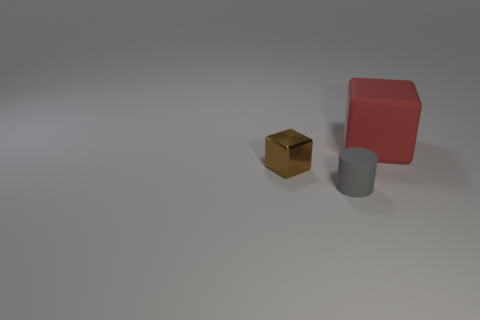Are there more gray cylinders that are in front of the tiny metal cube than objects on the right side of the red rubber object?
Your answer should be compact. Yes. What is the shape of the brown object that is the same size as the gray matte thing?
Ensure brevity in your answer.  Cube. What number of objects are small matte things or things on the left side of the large red matte cube?
Your answer should be compact. 2. There is a red rubber thing; how many tiny metal objects are in front of it?
Offer a terse response. 1. There is a cube that is the same material as the gray cylinder; what is its color?
Your answer should be very brief. Red. How many matte objects are blue cubes or tiny brown cubes?
Provide a short and direct response. 0. Does the big cube have the same material as the brown block?
Your answer should be compact. No. There is a matte object to the left of the red matte cube; what is its shape?
Offer a very short reply. Cylinder. There is a matte object on the right side of the gray object; are there any cylinders left of it?
Keep it short and to the point. Yes. Is there a brown object of the same size as the rubber cylinder?
Provide a short and direct response. Yes. 